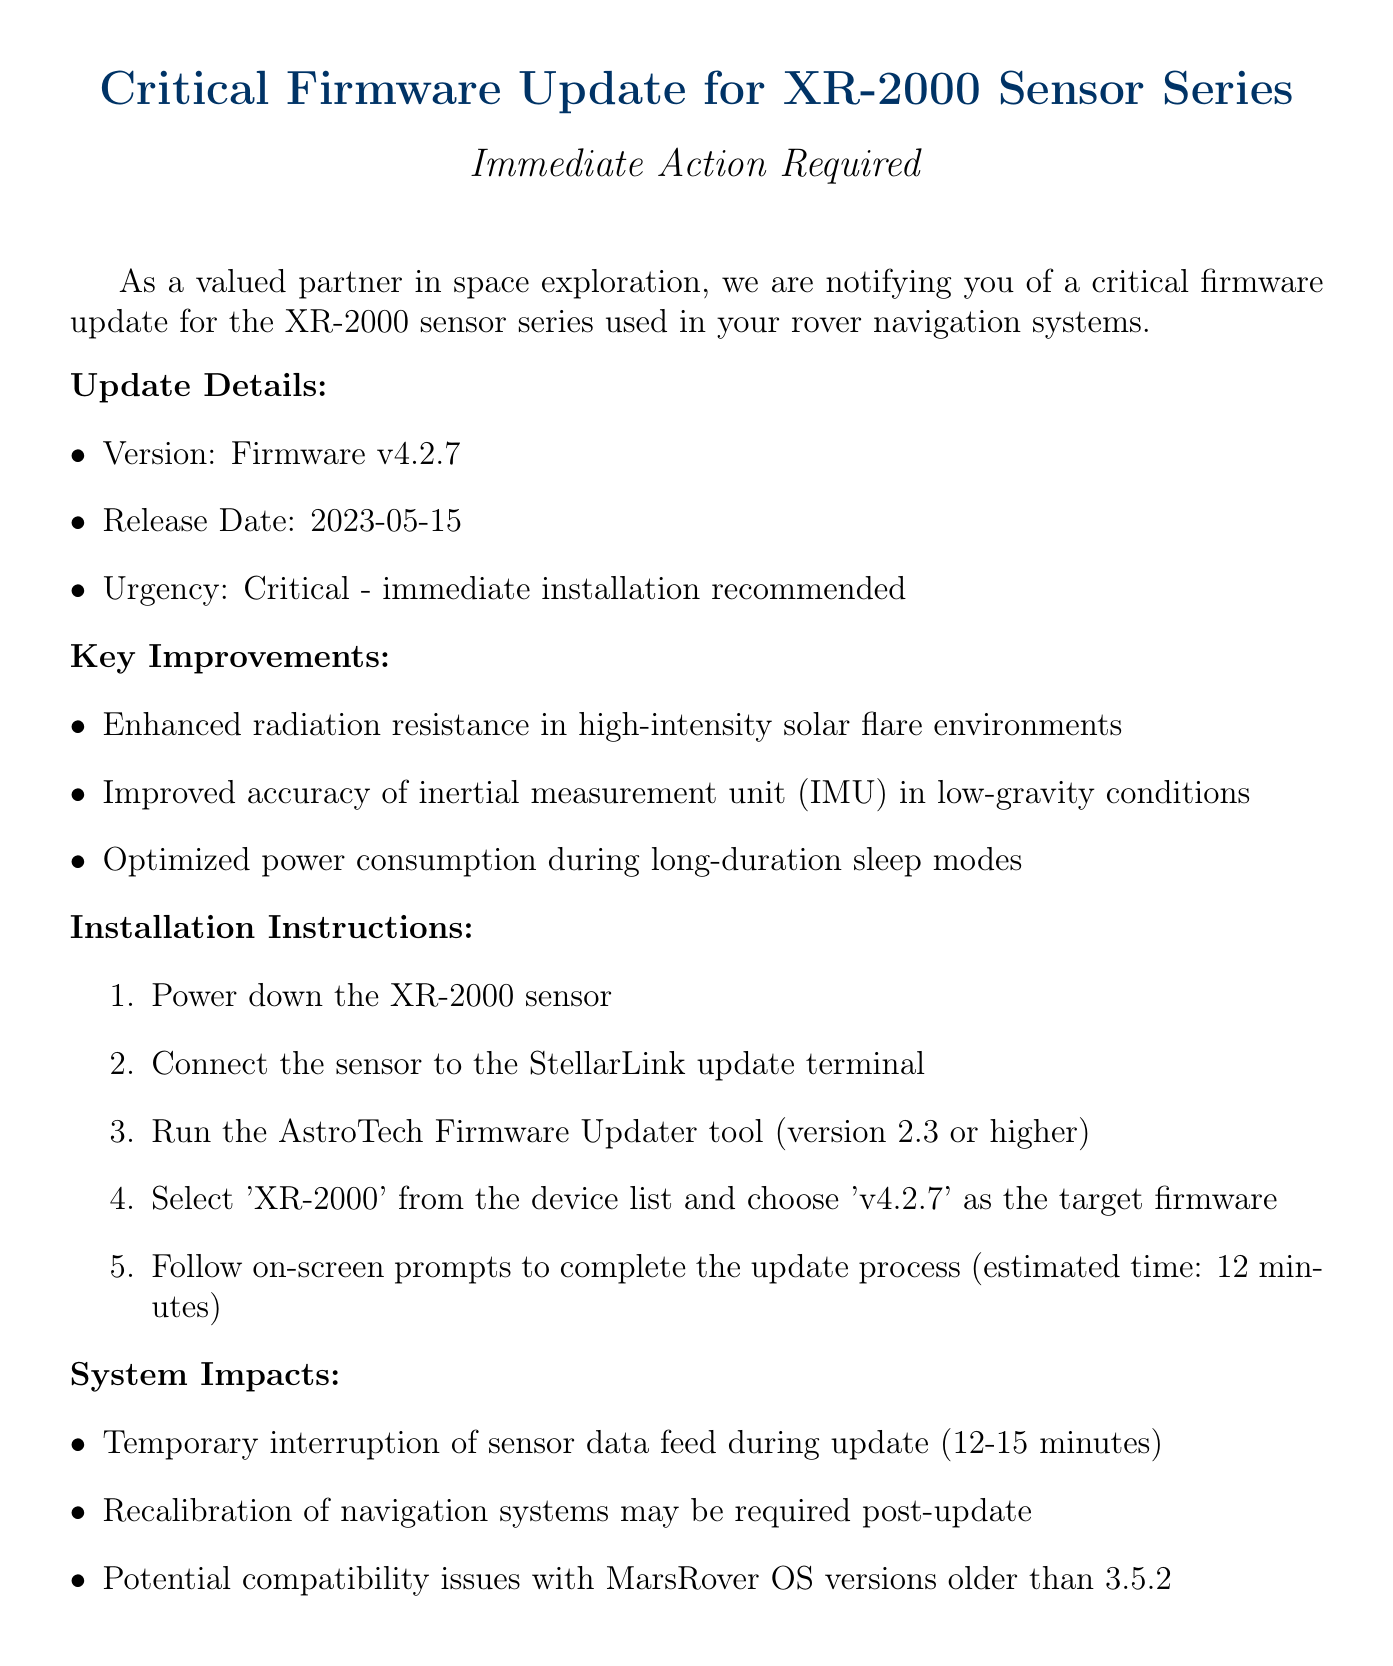What is the version of the firmware? The version of the firmware is stated explicitly in the document as Firmware v4.2.7.
Answer: Firmware v4.2.7 When was the firmware released? The release date of the firmware is directly mentioned in the document, which is 2023-05-15.
Answer: 2023-05-15 What is the urgency level of the update? The document specifies the urgency level as "Critical - immediate installation recommended."
Answer: Critical - immediate installation recommended What improvement relates to low-gravity conditions? This refers to the improvement mentioned regarding the accuracy of the inertial measurement unit (IMU) in low-gravity conditions in the key improvements section.
Answer: Improved accuracy of inertial measurement unit (IMU) in low-gravity conditions How long is the estimated update process? The document indicates that the estimated time for the update process is 12 minutes.
Answer: 12 minutes What may be required post-update? The document highlights that recalibration of navigation systems may be required after the update.
Answer: Recalibration of navigation systems What temporary impact will occur during the update? The document states that there will be a temporary interruption of sensor data feed during the update.
Answer: Temporary interruption of sensor data feed Which OS version might face compatibility issues? The compatibility issues are noted for MarsRover OS versions older than 3.5.2 in the system impacts section.
Answer: MarsRover OS versions older than 3.5.2 Who should be contacted for support? The document provides specific contact information, indicating the AstroTech Support Team for assistance.
Answer: AstroTech Support Team 